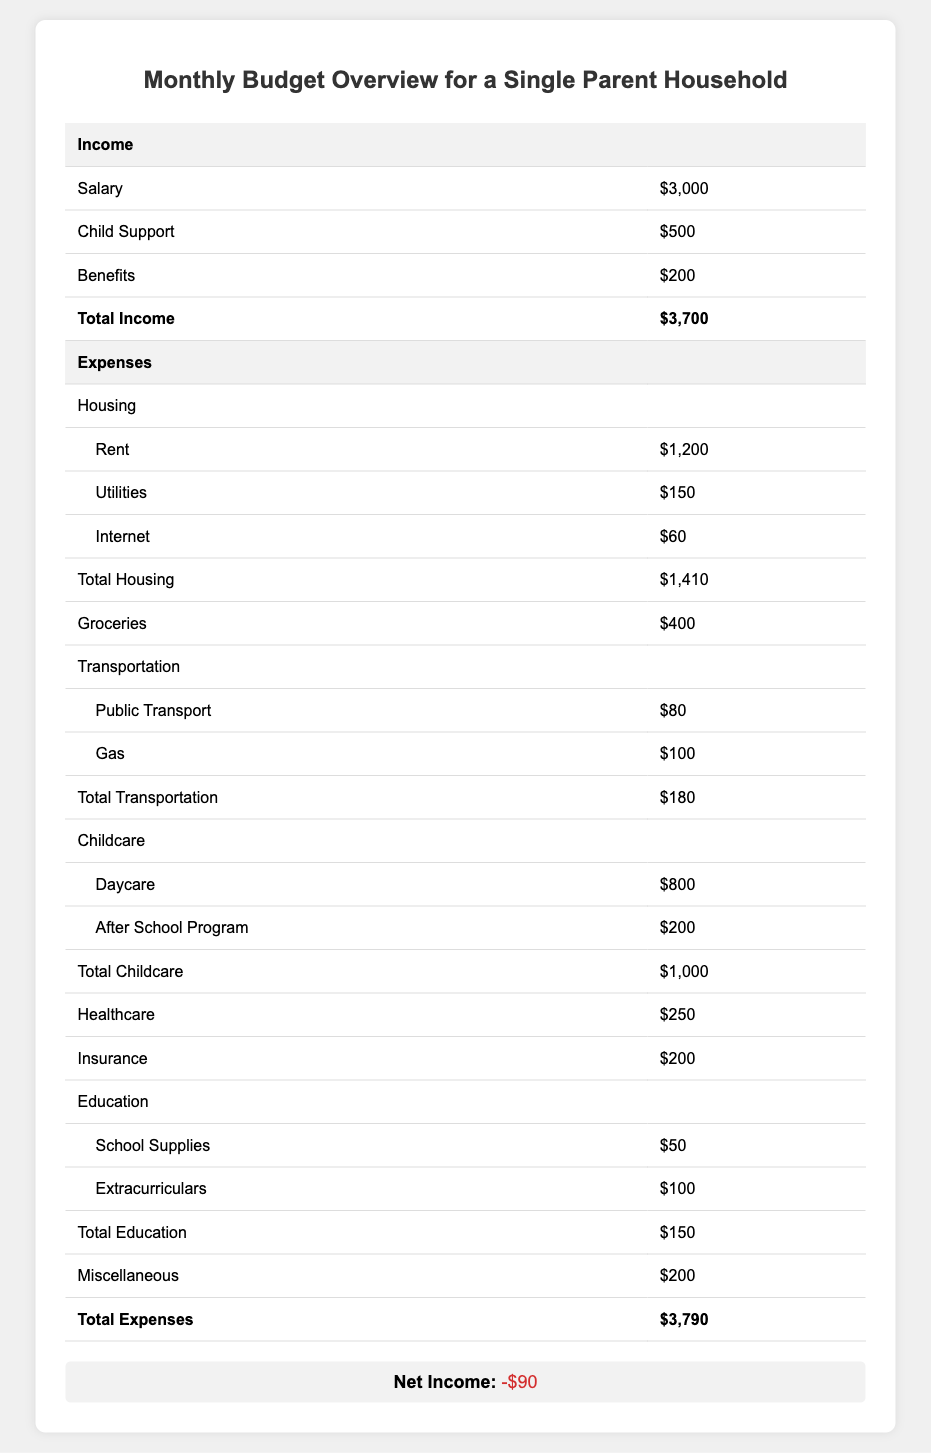What is the total income for the household? The total income is explicitly stated in the table under the 'Income' section as $3,700.
Answer: $3,700 What is the total amount spent on housing? The total housing expenses are provided in the table as $1,410, which includes rent, utilities, and internet costs.
Answer: $1,410 How much is spent on groceries? The table indicates that $400 is allocated for groceries under the 'Expenses' section.
Answer: $400 Is the net income positive or negative? The net income is shown as -$90, which indicates a negative balance.
Answer: Negative What is the combined total for transportation expenses? The transportation expenses total $180, which is derived from summing public transport ($80) and gas ($100) costs.
Answer: $180 How much does the household spend on childcare in total? The total childcare expenses amount to $1,000, including daycare and after-school program fees.
Answer: $1,000 If the household wanted to save $50 this month, what adjustments would they need to make to their expenses? To save $50, the household needs to reduce expenses from $3,790 to $3,740. They currently have a net income of -$90, so they need to cut $50 from their total expenses to achieve their goal.
Answer: Cut $50 from expenses What is the total healthcare expense compared to the amount spent on education? The total healthcare expense is $250 and the total education expense is $150. Therefore, the healthcare expenses exceed education expenses by $100.
Answer: $100 more on healthcare What percentage of the total income is spent on housing? The percentage spent on housing is calculated by dividing total housing expenses ($1,410) by total income ($3,700) and multiplying by 100. This results in approximately 38.11%.
Answer: 38.11% How much would the household save if they cut miscellaneous expenses in half? The miscellaneous expenses are $200; cutting these in half would save $100, changing their net income from -$90 to +$10.
Answer: $100 savings 